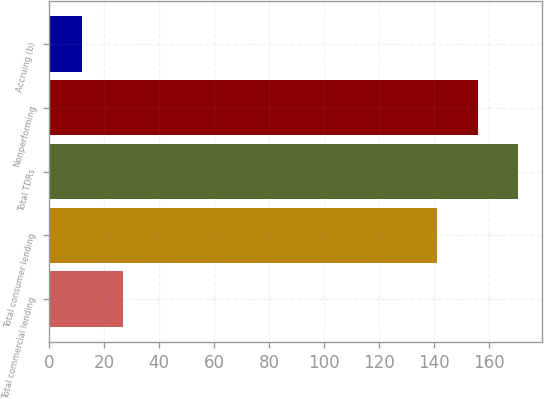Convert chart to OTSL. <chart><loc_0><loc_0><loc_500><loc_500><bar_chart><fcel>Total commercial lending<fcel>Total consumer lending<fcel>Total TDRs<fcel>Nonperforming<fcel>Accruing (b)<nl><fcel>26.8<fcel>141<fcel>170.6<fcel>155.8<fcel>12<nl></chart> 